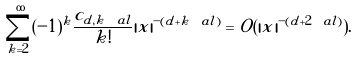<formula> <loc_0><loc_0><loc_500><loc_500>\sum _ { k = 2 } ^ { \infty } ( - 1 ) ^ { k } \frac { c _ { d , k \ a l } } { k ! } | x | ^ { - ( d + k \ a l ) } = O ( | x | ^ { - ( d + 2 \ a l ) } ) .</formula> 